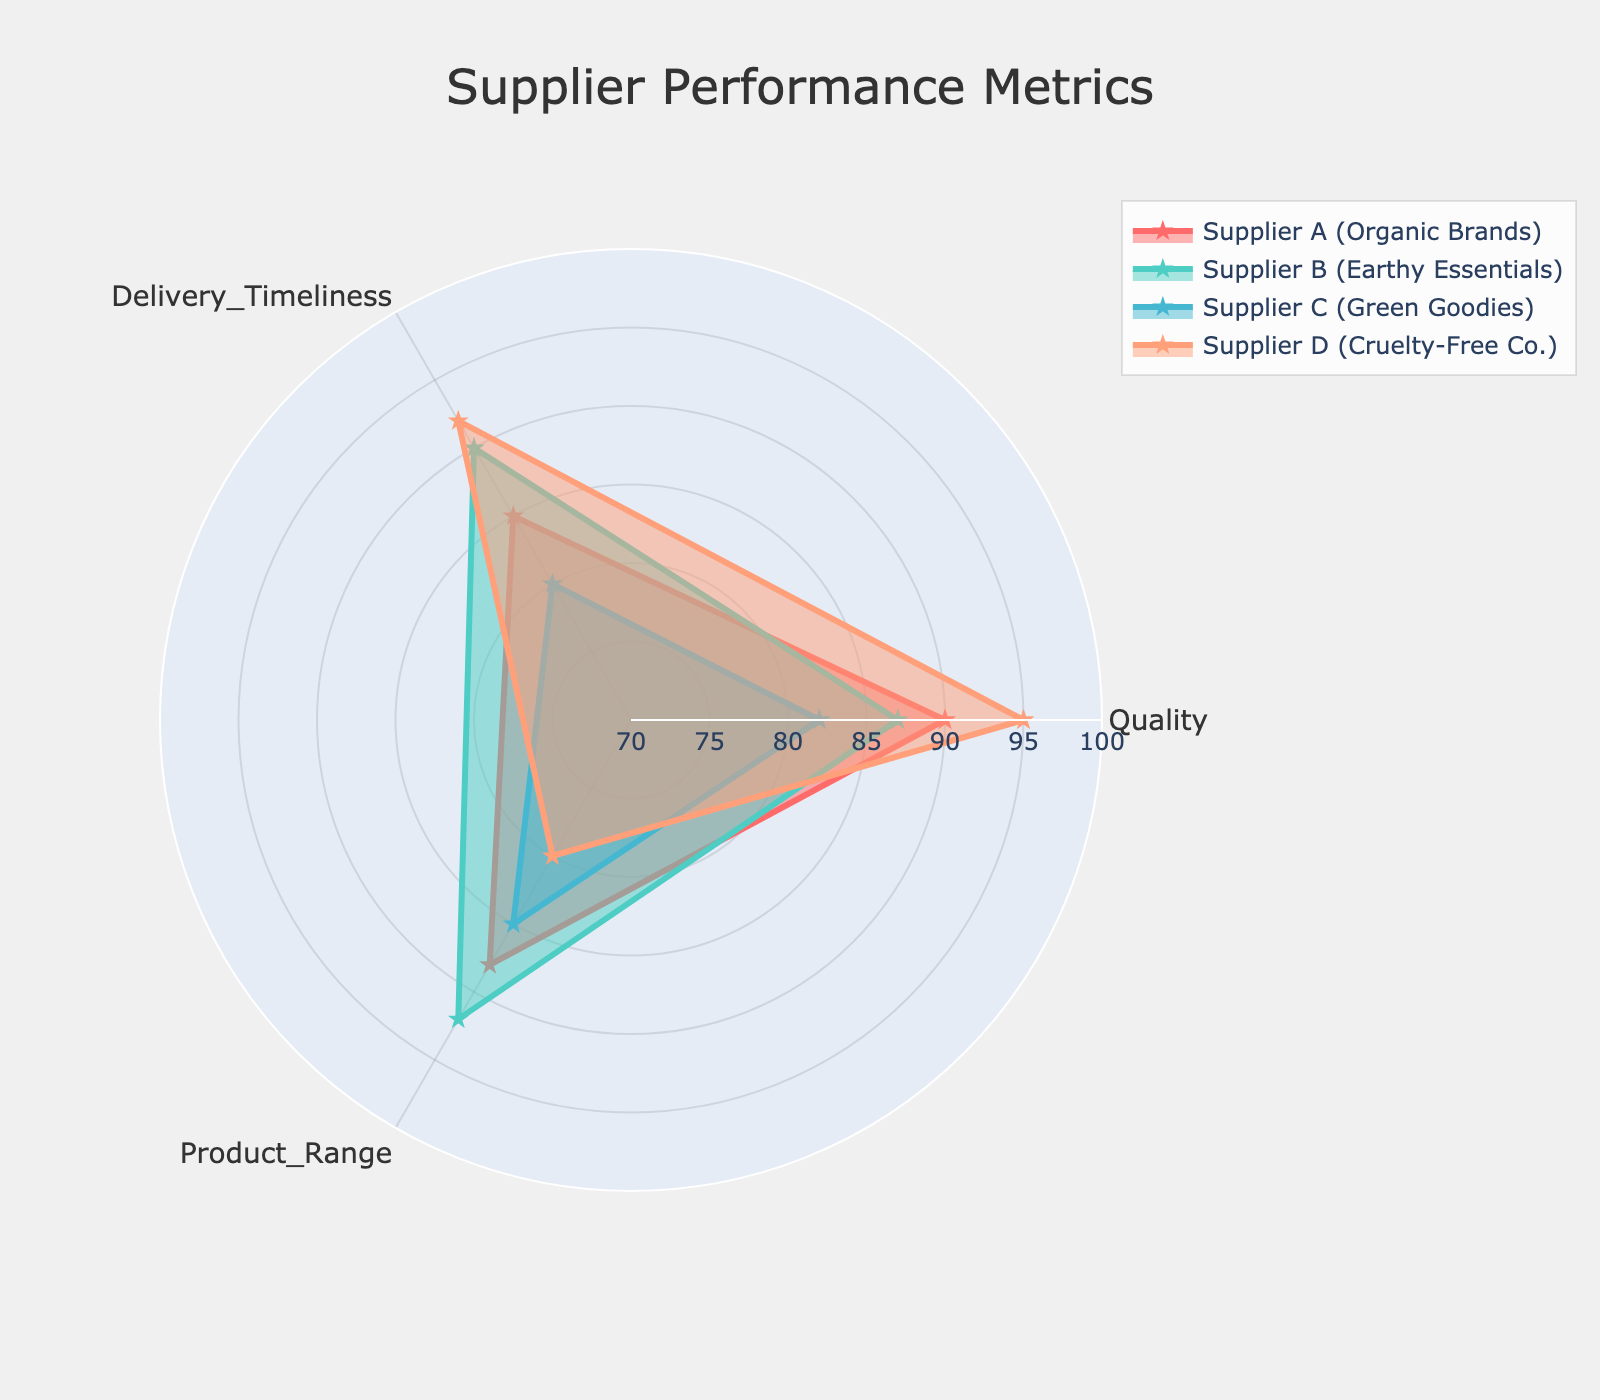What are the three performance metrics evaluated in the radar chart? The radar chart evaluates each supplier based on three performance metrics: Quality, Delivery Timeliness, and Product Range, which are displayed on the axes of the chart.
Answer: Quality, Delivery Timeliness, and Product Range Which supplier has the highest score in Quality? By examining Quality on the radar chart, Supplier D (Cruelty-Free Co.) has the highest value of 95 compared to others.
Answer: Supplier D What is the difference in Product Range scores between Supplier B and Supplier D? Supplier B has a Product Range score of 92, while Supplier D has a score of 80. The difference is calculated as 92 - 80.
Answer: 12 Which supplier has the lowest Delivery Timeliness score? The Delivery Timeliness scores are 85 for Supplier A, 90 for Supplier B, 80 for Supplier C, and 92 for Supplier D. The lowest score is 80, belonging to Supplier C.
Answer: Supplier C Compare the Quality scores between Supplier A and Supplier C. Which one is higher and by how much? Supplier A has a Quality score of 90, and Supplier C has 82. The difference is 90 - 82.
Answer: Supplier A by 8 Which supplier's performance is the most balanced across the three metrics? A balanced performance would mean relatively similar scores across all metrics. Supplier B has the following scores: Quality 87, Delivery Timeliness 90, and Product Range 92, which are the most close together.
Answer: Supplier B Calculate the average score for Supplier B across all metrics. Supplier B's scores are: Quality 87, Delivery Timeliness 90, and Product Range 92. The average is calculated as (87 + 90 + 92)/3.
Answer: 89.67 What is the total score (sum) across all metrics for Supplier C? Supplier C's scores are: Quality 82, Delivery Timeliness 80, and Product Range 85. The total is calculated as 82 + 80 + 85.
Answer: 247 Which supplier has the highest average score across all metrics? To find the highest average, calculate the average for each supplier: Supplier A (90+85+88)/3 = 87.67, Supplier B (87+90+92)/3 = 89.67, Supplier C (82+80+85)/3 = 82.33, and Supplier D (95+92+80)/3 = 89. This shows that Supplier B has the highest average score.
Answer: Supplier B Between Supplier A and Supplier D, which one has a better Product Range score and by what margin? Supplier A has a Product Range score of 88 and Supplier D has 80. The difference is 88 - 80.
Answer: Supplier A by 8 